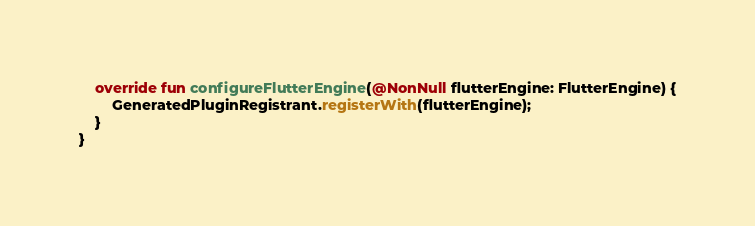Convert code to text. <code><loc_0><loc_0><loc_500><loc_500><_Kotlin_>    override fun configureFlutterEngine(@NonNull flutterEngine: FlutterEngine) {
        GeneratedPluginRegistrant.registerWith(flutterEngine);
    }
}
</code> 